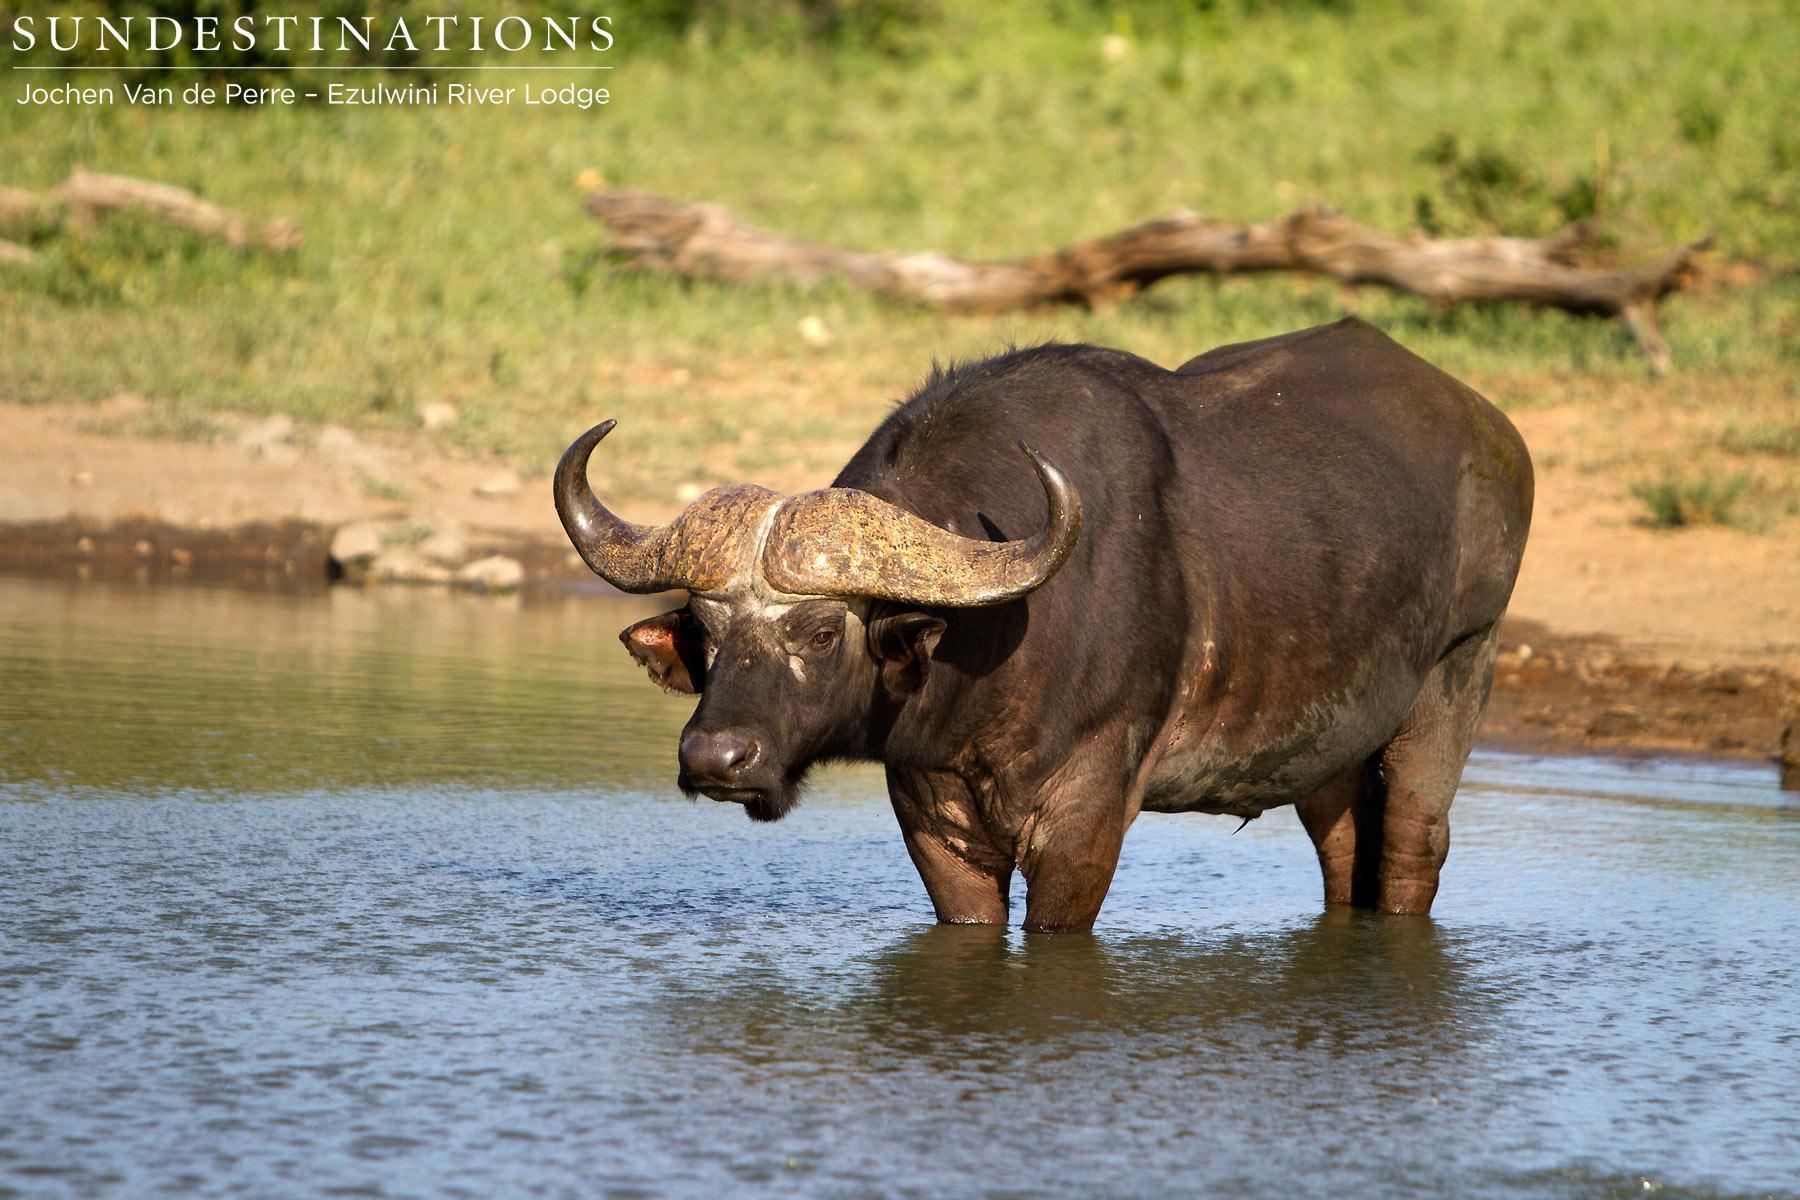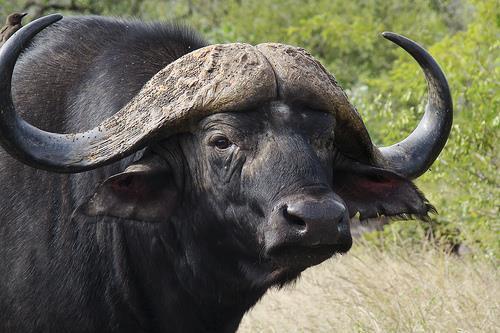The first image is the image on the left, the second image is the image on the right. Analyze the images presented: Is the assertion "There are two adult horned buffalo and no water." valid? Answer yes or no. No. The first image is the image on the left, the second image is the image on the right. Given the left and right images, does the statement "In the image to the left, the ox is standing, surrounded by GREEN vegetation/grass." hold true? Answer yes or no. No. 